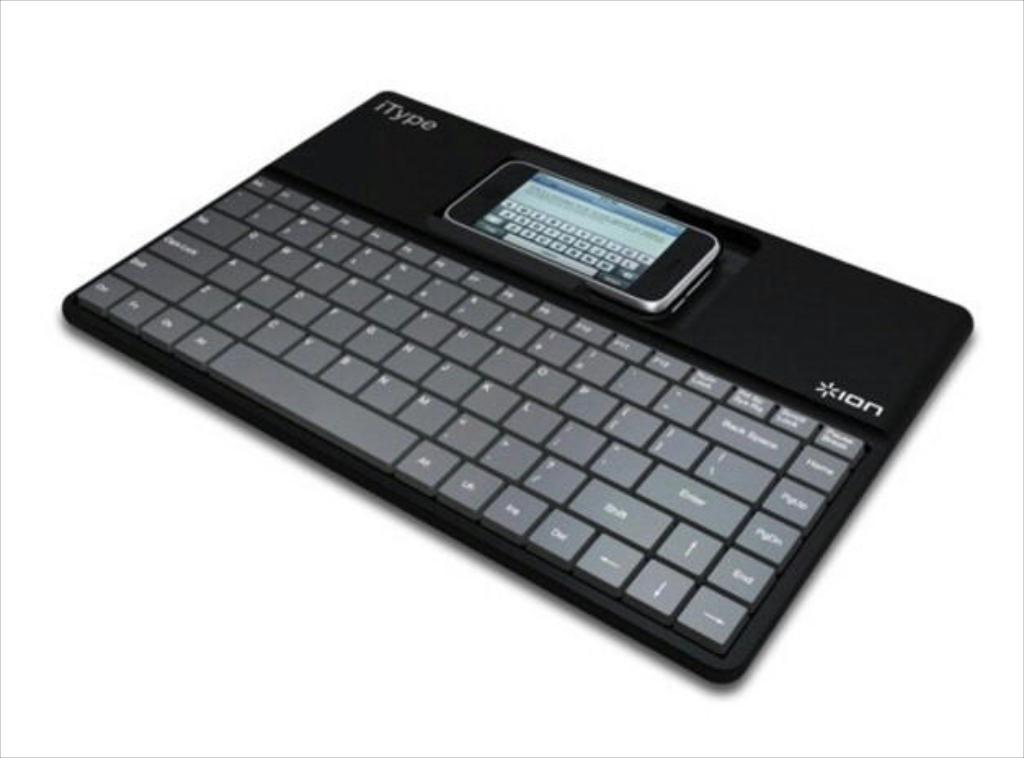<image>
Summarize the visual content of the image. A device called an iType, which is made by Ion. 